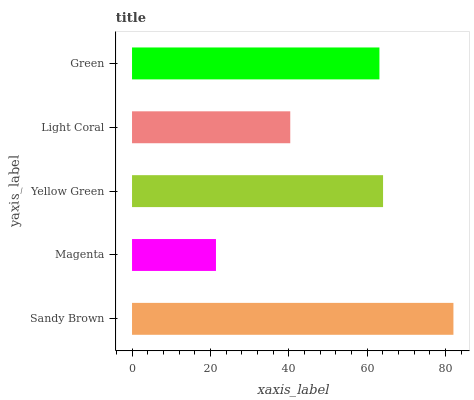Is Magenta the minimum?
Answer yes or no. Yes. Is Sandy Brown the maximum?
Answer yes or no. Yes. Is Yellow Green the minimum?
Answer yes or no. No. Is Yellow Green the maximum?
Answer yes or no. No. Is Yellow Green greater than Magenta?
Answer yes or no. Yes. Is Magenta less than Yellow Green?
Answer yes or no. Yes. Is Magenta greater than Yellow Green?
Answer yes or no. No. Is Yellow Green less than Magenta?
Answer yes or no. No. Is Green the high median?
Answer yes or no. Yes. Is Green the low median?
Answer yes or no. Yes. Is Sandy Brown the high median?
Answer yes or no. No. Is Sandy Brown the low median?
Answer yes or no. No. 